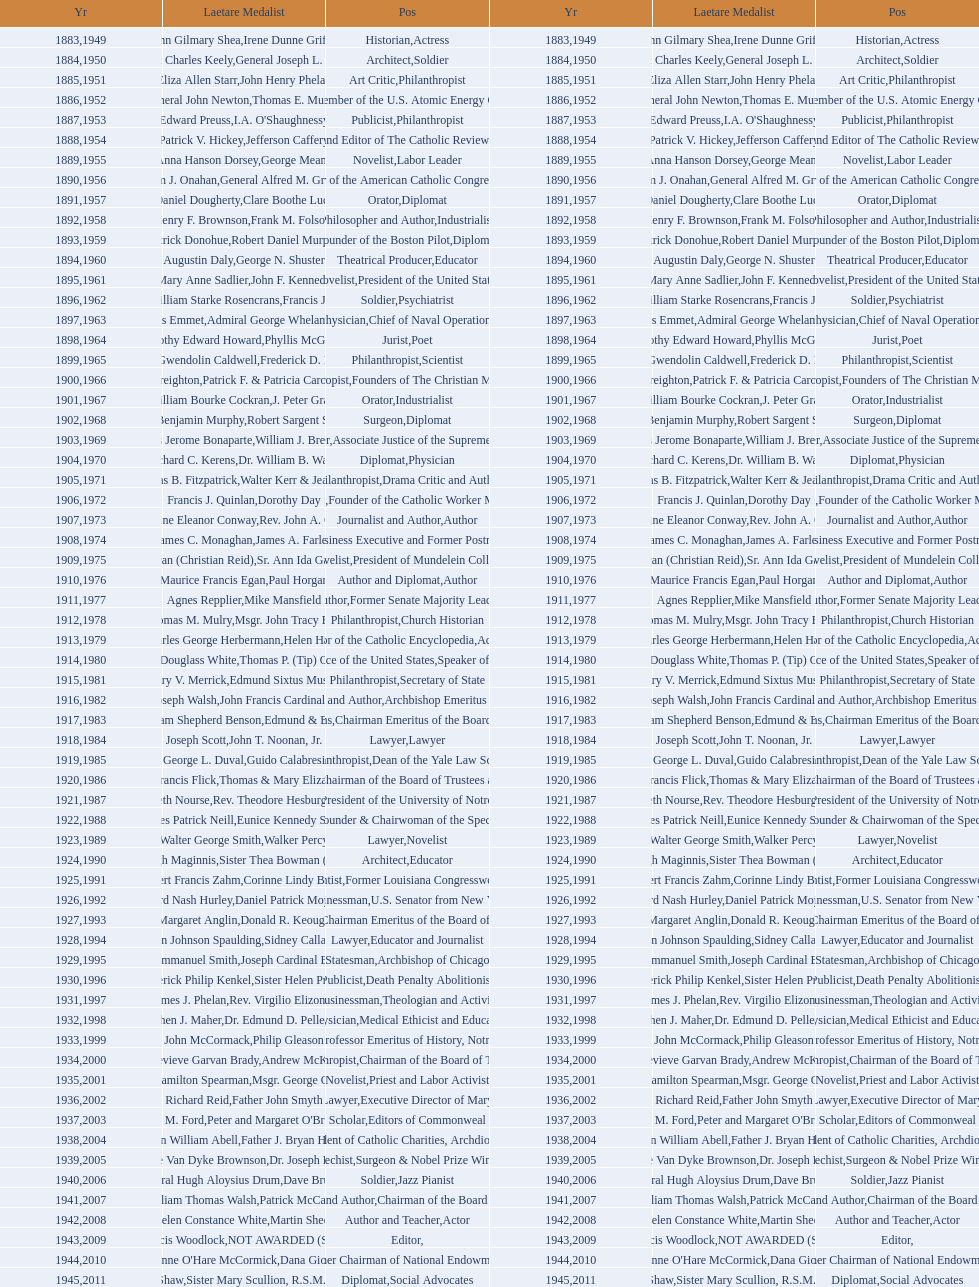What are the total number of times soldier is listed as the position on this chart? 4. 